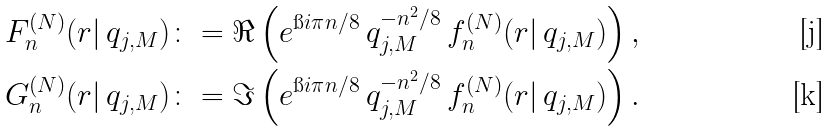Convert formula to latex. <formula><loc_0><loc_0><loc_500><loc_500>F _ { n } ^ { ( N ) } ( r | \, q _ { j , M } ) & \colon = \Re \left ( e ^ { \i i \pi n / 8 } \, q _ { j , M } ^ { - n ^ { 2 } / 8 } \, f _ { n } ^ { ( N ) } ( r | \, q _ { j , M } ) \right ) , \\ G _ { n } ^ { ( N ) } ( r | \, q _ { j , M } ) & \colon = \Im \left ( e ^ { \i i \pi n / 8 } \, q _ { j , M } ^ { - n ^ { 2 } / 8 } \, f _ { n } ^ { ( N ) } ( r | \, q _ { j , M } ) \right ) .</formula> 